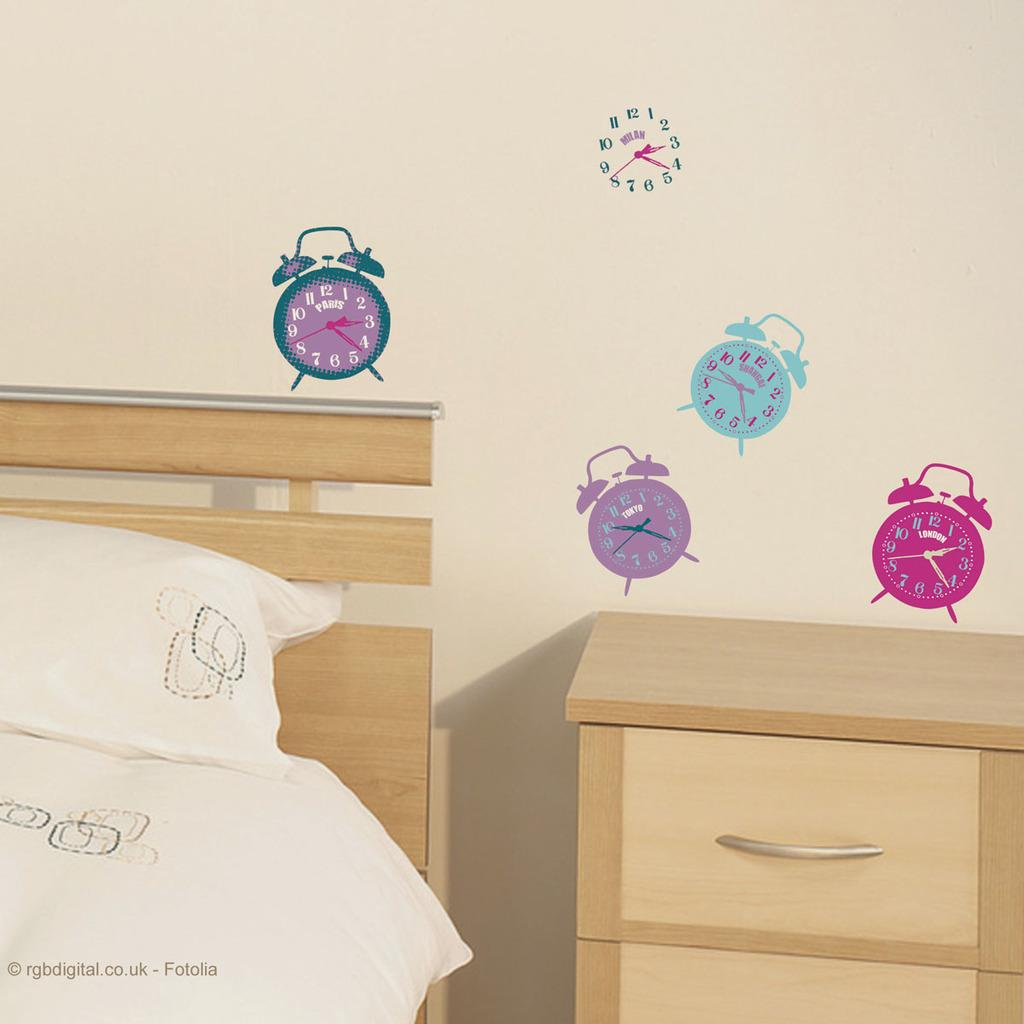<image>
Create a compact narrative representing the image presented. A wall displaying clocks showing times from around the world including Paris and Milan. 